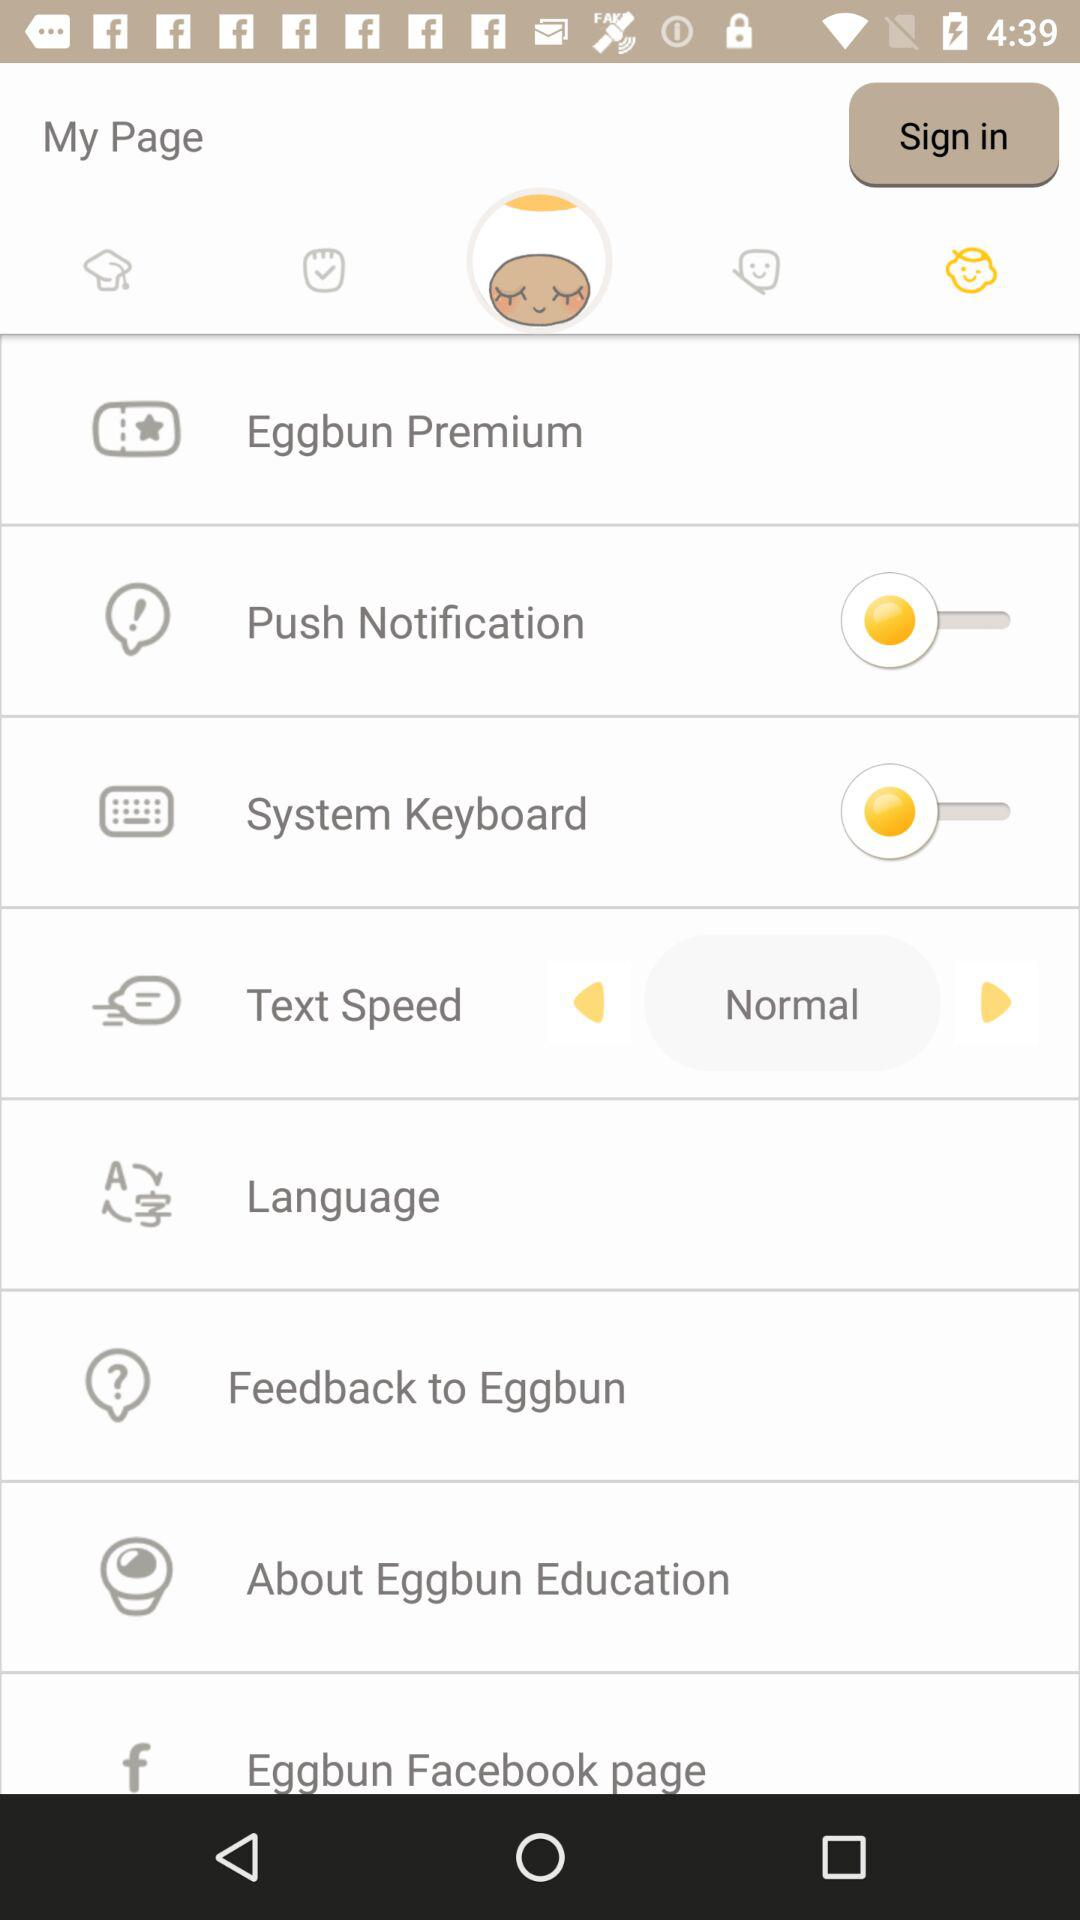Is the "System Keyboard" on or off? The "System Keyboard" is "off". 